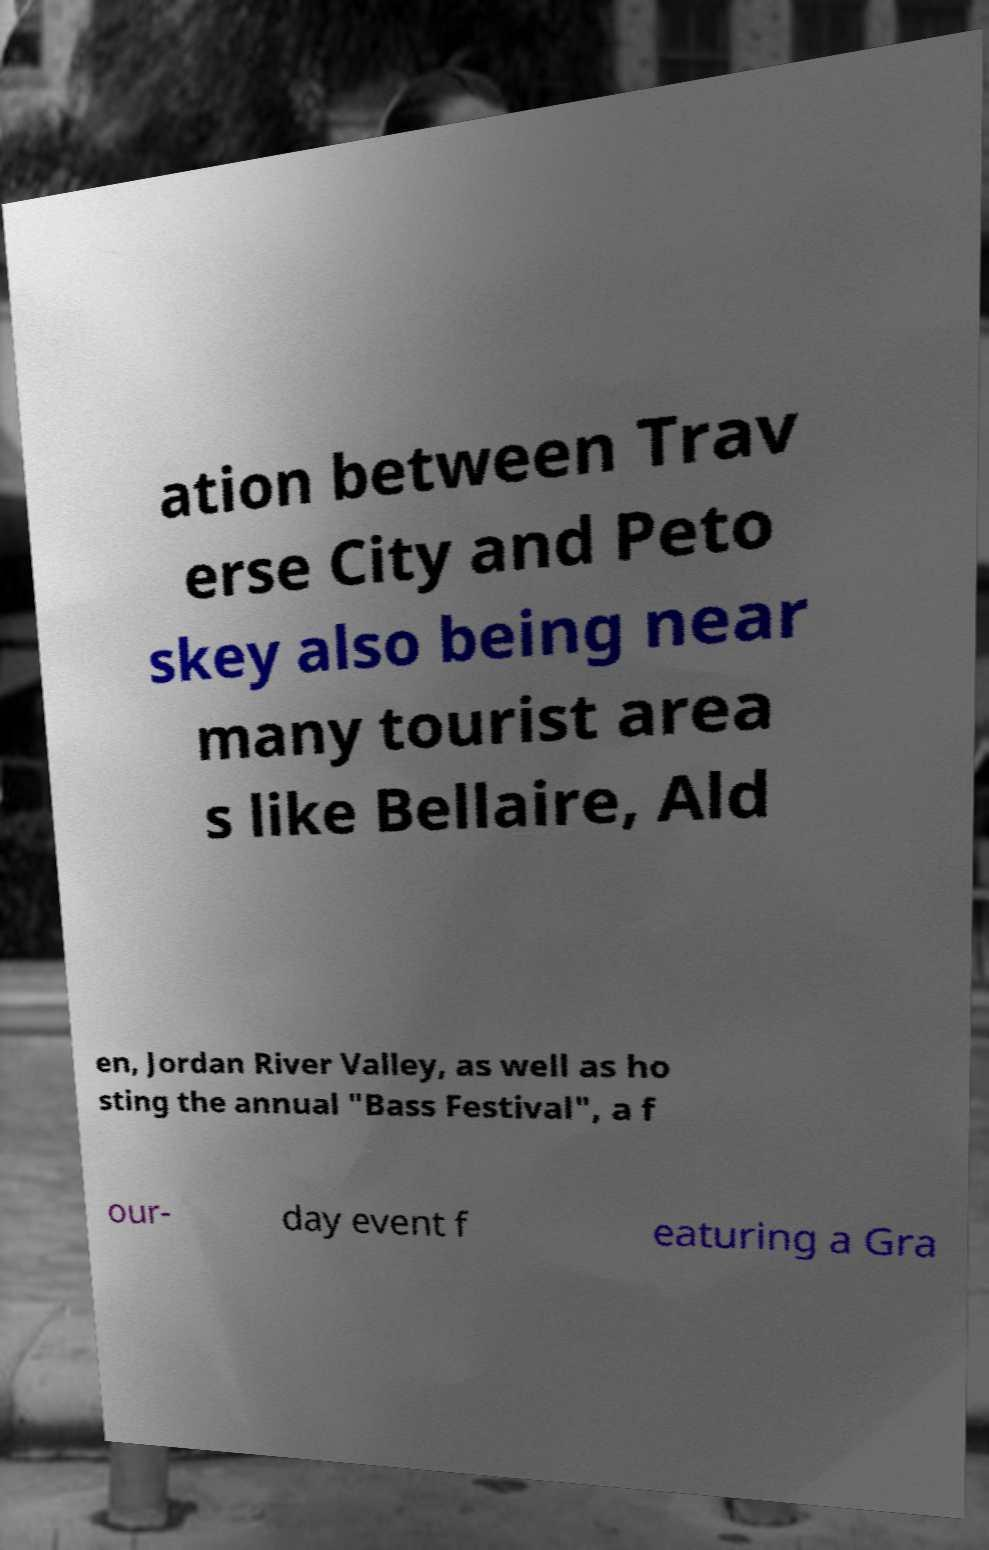There's text embedded in this image that I need extracted. Can you transcribe it verbatim? ation between Trav erse City and Peto skey also being near many tourist area s like Bellaire, Ald en, Jordan River Valley, as well as ho sting the annual "Bass Festival", a f our- day event f eaturing a Gra 